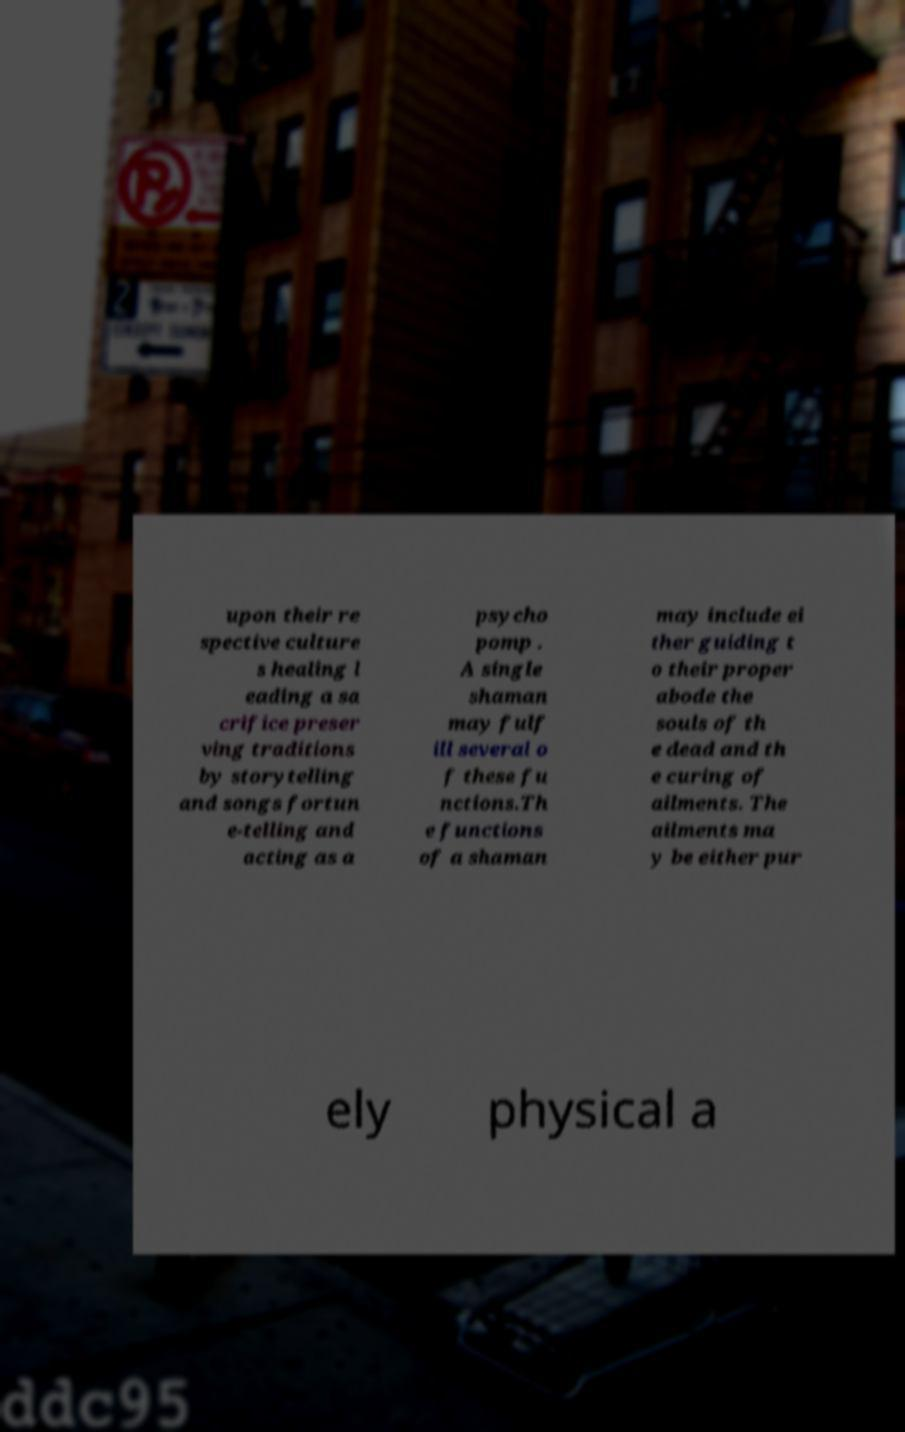Please identify and transcribe the text found in this image. upon their re spective culture s healing l eading a sa crifice preser ving traditions by storytelling and songs fortun e-telling and acting as a psycho pomp . A single shaman may fulf ill several o f these fu nctions.Th e functions of a shaman may include ei ther guiding t o their proper abode the souls of th e dead and th e curing of ailments. The ailments ma y be either pur ely physical a 